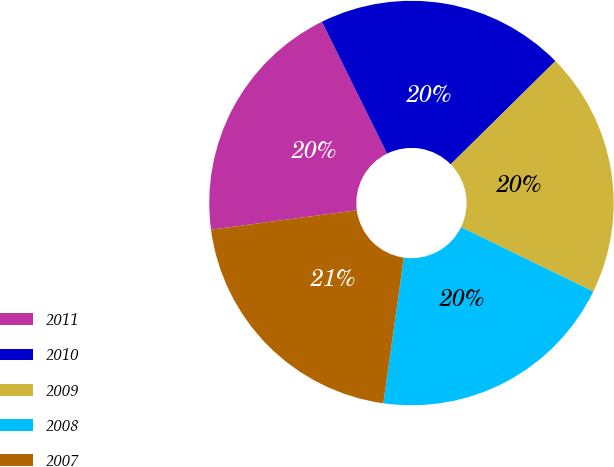<chart> <loc_0><loc_0><loc_500><loc_500><pie_chart><fcel>2011<fcel>2010<fcel>2009<fcel>2008<fcel>2007<nl><fcel>19.8%<fcel>19.91%<fcel>19.6%<fcel>20.01%<fcel>20.68%<nl></chart> 